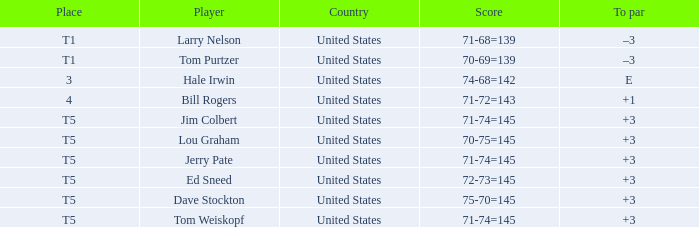Who is the player that has a score of 70-75=145? Lou Graham. 